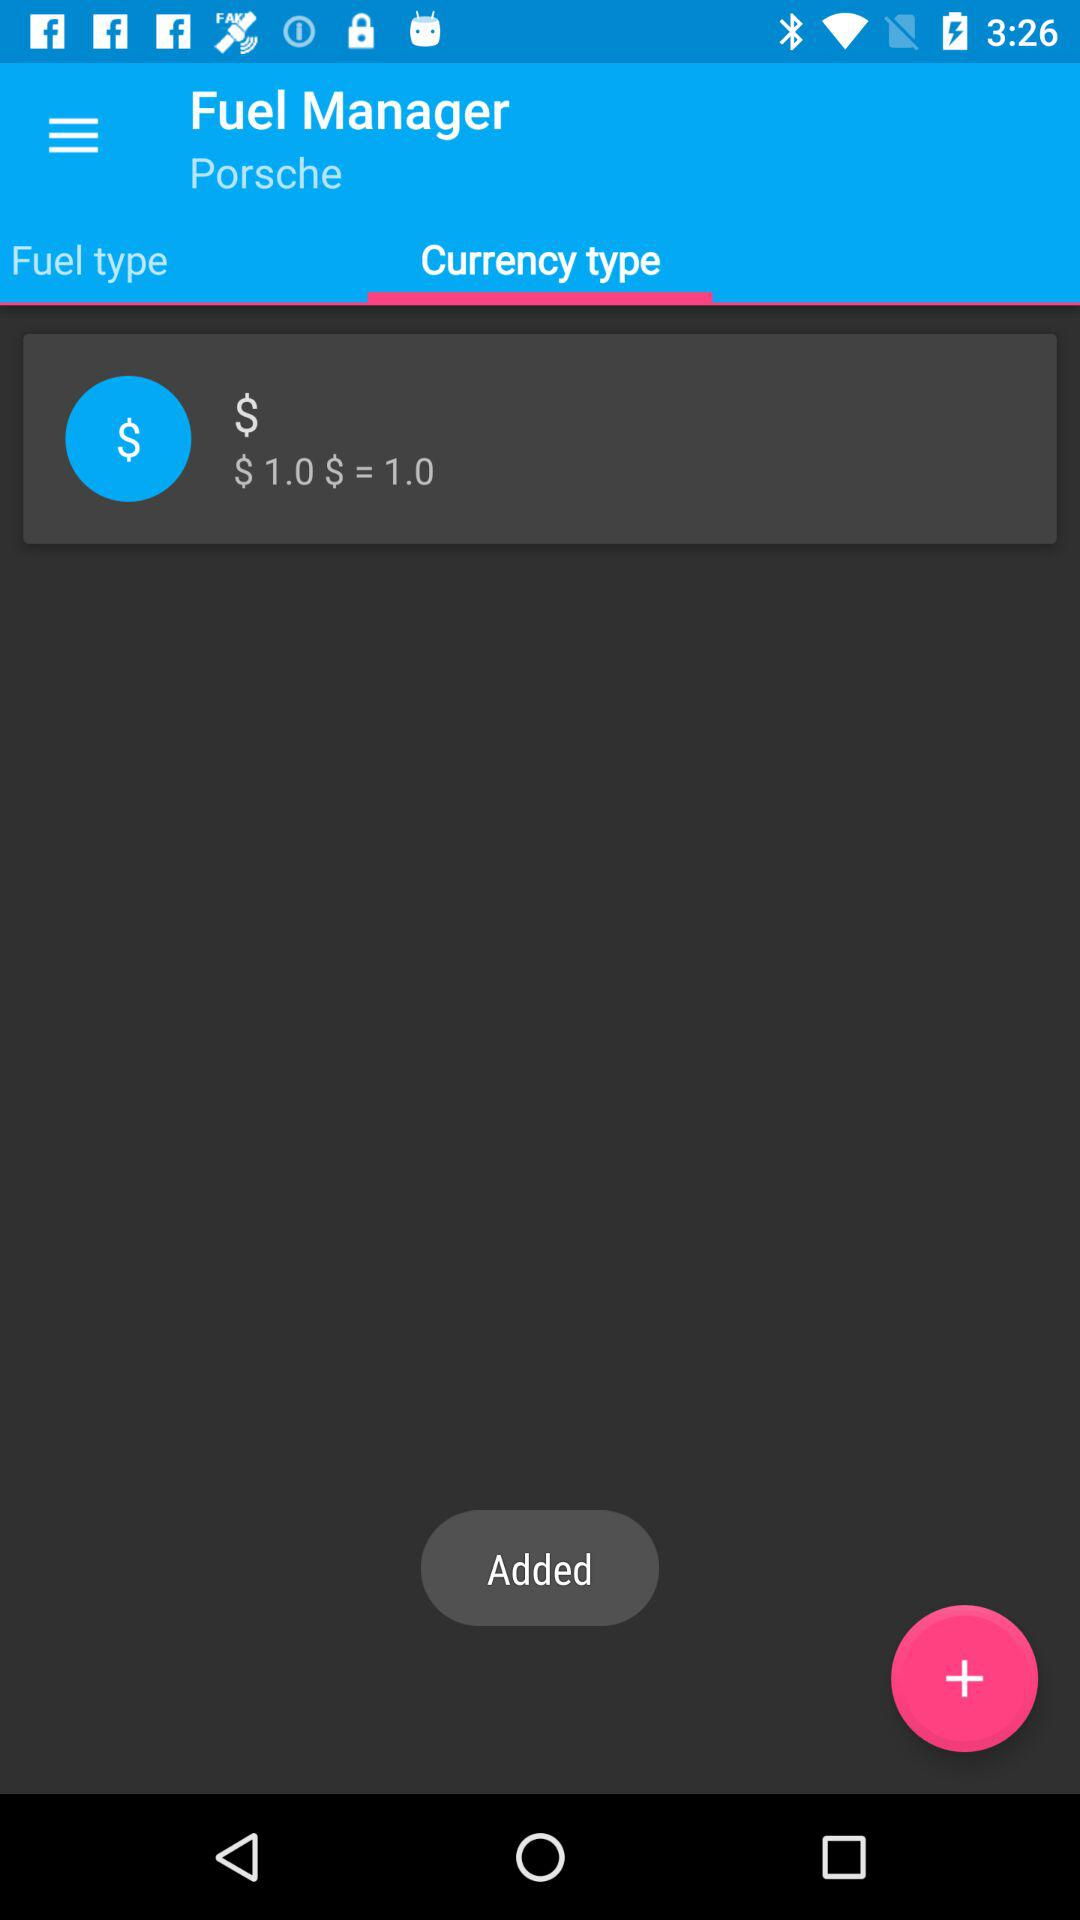What is the currency type?
Answer the question using a single word or phrase. $ 